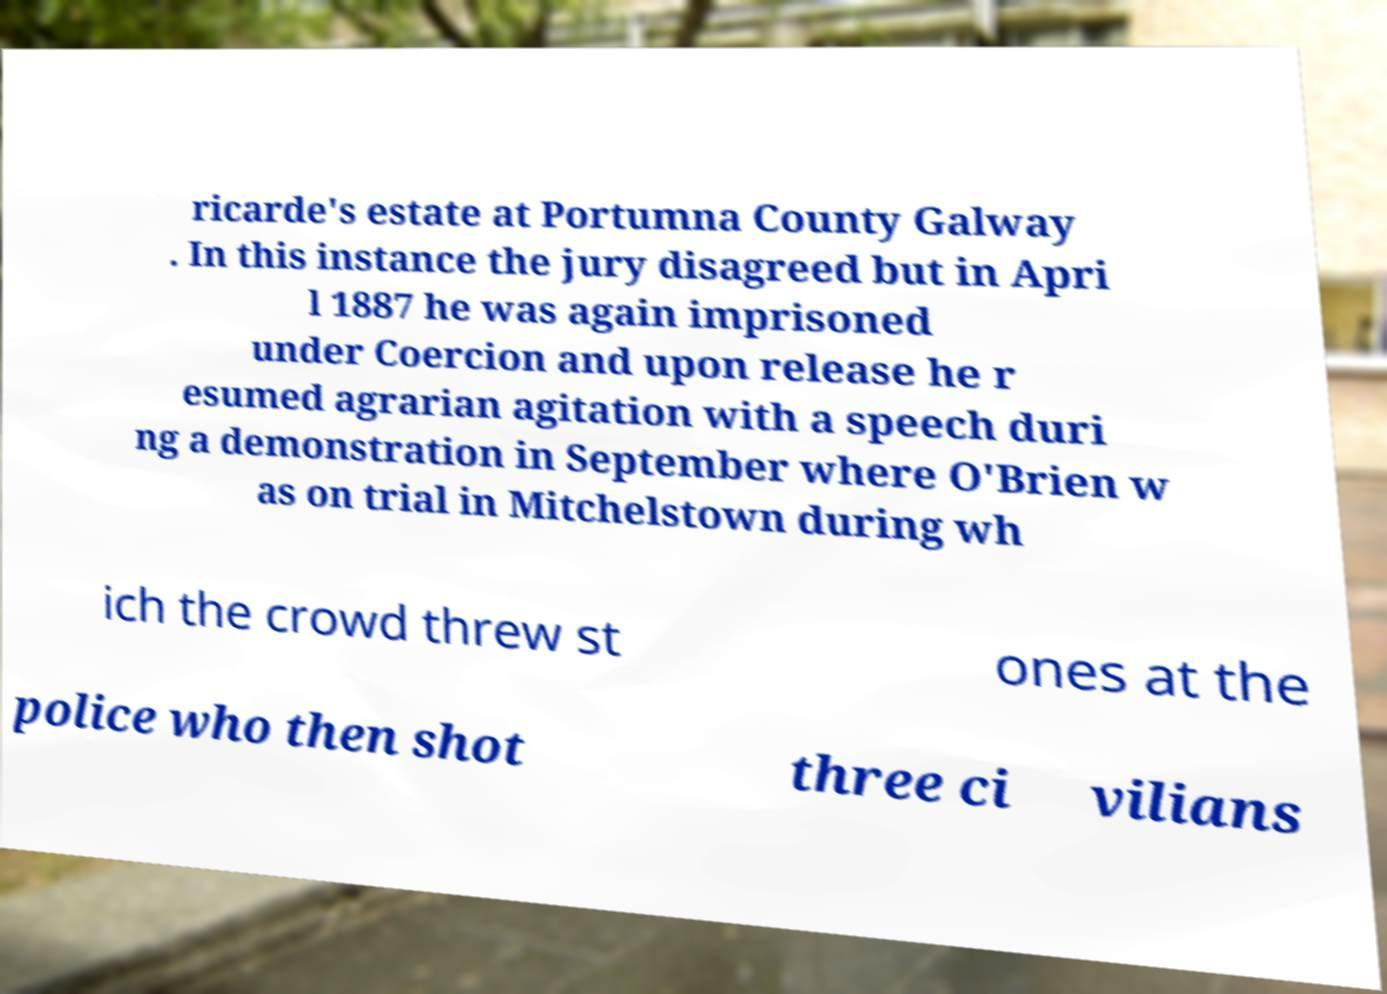Please identify and transcribe the text found in this image. ricarde's estate at Portumna County Galway . In this instance the jury disagreed but in Apri l 1887 he was again imprisoned under Coercion and upon release he r esumed agrarian agitation with a speech duri ng a demonstration in September where O'Brien w as on trial in Mitchelstown during wh ich the crowd threw st ones at the police who then shot three ci vilians 